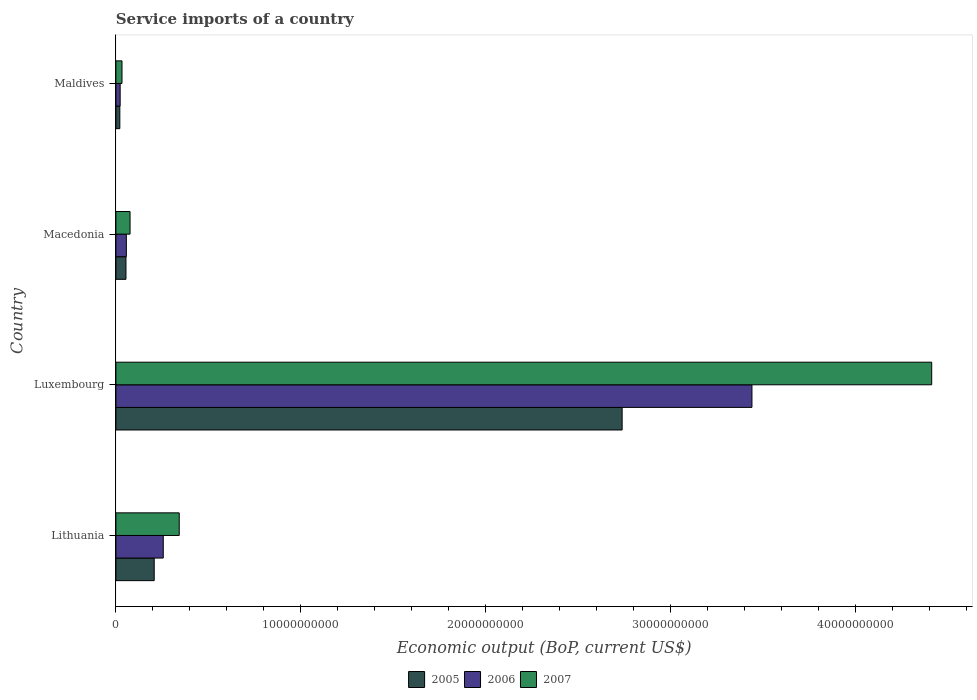How many different coloured bars are there?
Provide a succinct answer. 3. How many bars are there on the 2nd tick from the bottom?
Your answer should be very brief. 3. What is the label of the 1st group of bars from the top?
Your answer should be compact. Maldives. What is the service imports in 2007 in Lithuania?
Keep it short and to the point. 3.43e+09. Across all countries, what is the maximum service imports in 2005?
Offer a very short reply. 2.74e+1. Across all countries, what is the minimum service imports in 2007?
Provide a succinct answer. 3.31e+08. In which country was the service imports in 2005 maximum?
Give a very brief answer. Luxembourg. In which country was the service imports in 2007 minimum?
Your answer should be compact. Maldives. What is the total service imports in 2007 in the graph?
Your answer should be compact. 4.87e+1. What is the difference between the service imports in 2007 in Lithuania and that in Macedonia?
Ensure brevity in your answer.  2.66e+09. What is the difference between the service imports in 2007 in Maldives and the service imports in 2006 in Lithuania?
Provide a succinct answer. -2.23e+09. What is the average service imports in 2005 per country?
Your answer should be compact. 7.55e+09. What is the difference between the service imports in 2006 and service imports in 2007 in Lithuania?
Your answer should be compact. -8.64e+08. What is the ratio of the service imports in 2005 in Macedonia to that in Maldives?
Offer a very short reply. 2.56. Is the difference between the service imports in 2006 in Lithuania and Maldives greater than the difference between the service imports in 2007 in Lithuania and Maldives?
Offer a terse response. No. What is the difference between the highest and the second highest service imports in 2005?
Keep it short and to the point. 2.53e+1. What is the difference between the highest and the lowest service imports in 2006?
Your response must be concise. 3.42e+1. In how many countries, is the service imports in 2005 greater than the average service imports in 2005 taken over all countries?
Keep it short and to the point. 1. Is the sum of the service imports in 2005 in Macedonia and Maldives greater than the maximum service imports in 2007 across all countries?
Provide a succinct answer. No. What does the 3rd bar from the top in Lithuania represents?
Provide a short and direct response. 2005. What does the 3rd bar from the bottom in Macedonia represents?
Ensure brevity in your answer.  2007. Is it the case that in every country, the sum of the service imports in 2005 and service imports in 2007 is greater than the service imports in 2006?
Your answer should be compact. Yes. How many bars are there?
Provide a short and direct response. 12. Are all the bars in the graph horizontal?
Offer a very short reply. Yes. How many countries are there in the graph?
Ensure brevity in your answer.  4. Are the values on the major ticks of X-axis written in scientific E-notation?
Keep it short and to the point. No. How are the legend labels stacked?
Provide a succinct answer. Horizontal. What is the title of the graph?
Ensure brevity in your answer.  Service imports of a country. Does "1983" appear as one of the legend labels in the graph?
Your answer should be very brief. No. What is the label or title of the X-axis?
Make the answer very short. Economic output (BoP, current US$). What is the Economic output (BoP, current US$) in 2005 in Lithuania?
Keep it short and to the point. 2.07e+09. What is the Economic output (BoP, current US$) of 2006 in Lithuania?
Ensure brevity in your answer.  2.56e+09. What is the Economic output (BoP, current US$) of 2007 in Lithuania?
Provide a succinct answer. 3.43e+09. What is the Economic output (BoP, current US$) in 2005 in Luxembourg?
Your answer should be compact. 2.74e+1. What is the Economic output (BoP, current US$) of 2006 in Luxembourg?
Provide a short and direct response. 3.44e+1. What is the Economic output (BoP, current US$) in 2007 in Luxembourg?
Your answer should be compact. 4.41e+1. What is the Economic output (BoP, current US$) in 2005 in Macedonia?
Keep it short and to the point. 5.45e+08. What is the Economic output (BoP, current US$) in 2006 in Macedonia?
Offer a terse response. 5.66e+08. What is the Economic output (BoP, current US$) in 2007 in Macedonia?
Give a very brief answer. 7.66e+08. What is the Economic output (BoP, current US$) of 2005 in Maldives?
Ensure brevity in your answer.  2.13e+08. What is the Economic output (BoP, current US$) of 2006 in Maldives?
Provide a short and direct response. 2.31e+08. What is the Economic output (BoP, current US$) in 2007 in Maldives?
Keep it short and to the point. 3.31e+08. Across all countries, what is the maximum Economic output (BoP, current US$) of 2005?
Your answer should be compact. 2.74e+1. Across all countries, what is the maximum Economic output (BoP, current US$) in 2006?
Your response must be concise. 3.44e+1. Across all countries, what is the maximum Economic output (BoP, current US$) of 2007?
Make the answer very short. 4.41e+1. Across all countries, what is the minimum Economic output (BoP, current US$) of 2005?
Your response must be concise. 2.13e+08. Across all countries, what is the minimum Economic output (BoP, current US$) of 2006?
Provide a short and direct response. 2.31e+08. Across all countries, what is the minimum Economic output (BoP, current US$) of 2007?
Offer a very short reply. 3.31e+08. What is the total Economic output (BoP, current US$) of 2005 in the graph?
Provide a succinct answer. 3.02e+1. What is the total Economic output (BoP, current US$) of 2006 in the graph?
Make the answer very short. 3.78e+1. What is the total Economic output (BoP, current US$) of 2007 in the graph?
Provide a succinct answer. 4.87e+1. What is the difference between the Economic output (BoP, current US$) in 2005 in Lithuania and that in Luxembourg?
Give a very brief answer. -2.53e+1. What is the difference between the Economic output (BoP, current US$) in 2006 in Lithuania and that in Luxembourg?
Your answer should be very brief. -3.18e+1. What is the difference between the Economic output (BoP, current US$) in 2007 in Lithuania and that in Luxembourg?
Give a very brief answer. -4.07e+1. What is the difference between the Economic output (BoP, current US$) in 2005 in Lithuania and that in Macedonia?
Keep it short and to the point. 1.53e+09. What is the difference between the Economic output (BoP, current US$) in 2006 in Lithuania and that in Macedonia?
Provide a short and direct response. 2.00e+09. What is the difference between the Economic output (BoP, current US$) of 2007 in Lithuania and that in Macedonia?
Your response must be concise. 2.66e+09. What is the difference between the Economic output (BoP, current US$) in 2005 in Lithuania and that in Maldives?
Provide a succinct answer. 1.86e+09. What is the difference between the Economic output (BoP, current US$) in 2006 in Lithuania and that in Maldives?
Make the answer very short. 2.33e+09. What is the difference between the Economic output (BoP, current US$) of 2007 in Lithuania and that in Maldives?
Provide a short and direct response. 3.10e+09. What is the difference between the Economic output (BoP, current US$) in 2005 in Luxembourg and that in Macedonia?
Your response must be concise. 2.68e+1. What is the difference between the Economic output (BoP, current US$) of 2006 in Luxembourg and that in Macedonia?
Your response must be concise. 3.38e+1. What is the difference between the Economic output (BoP, current US$) in 2007 in Luxembourg and that in Macedonia?
Your answer should be very brief. 4.34e+1. What is the difference between the Economic output (BoP, current US$) in 2005 in Luxembourg and that in Maldives?
Your answer should be compact. 2.72e+1. What is the difference between the Economic output (BoP, current US$) in 2006 in Luxembourg and that in Maldives?
Your answer should be compact. 3.42e+1. What is the difference between the Economic output (BoP, current US$) of 2007 in Luxembourg and that in Maldives?
Offer a terse response. 4.38e+1. What is the difference between the Economic output (BoP, current US$) in 2005 in Macedonia and that in Maldives?
Give a very brief answer. 3.32e+08. What is the difference between the Economic output (BoP, current US$) in 2006 in Macedonia and that in Maldives?
Offer a terse response. 3.35e+08. What is the difference between the Economic output (BoP, current US$) of 2007 in Macedonia and that in Maldives?
Your answer should be compact. 4.35e+08. What is the difference between the Economic output (BoP, current US$) in 2005 in Lithuania and the Economic output (BoP, current US$) in 2006 in Luxembourg?
Give a very brief answer. -3.23e+1. What is the difference between the Economic output (BoP, current US$) in 2005 in Lithuania and the Economic output (BoP, current US$) in 2007 in Luxembourg?
Provide a succinct answer. -4.21e+1. What is the difference between the Economic output (BoP, current US$) of 2006 in Lithuania and the Economic output (BoP, current US$) of 2007 in Luxembourg?
Make the answer very short. -4.16e+1. What is the difference between the Economic output (BoP, current US$) in 2005 in Lithuania and the Economic output (BoP, current US$) in 2006 in Macedonia?
Provide a succinct answer. 1.51e+09. What is the difference between the Economic output (BoP, current US$) of 2005 in Lithuania and the Economic output (BoP, current US$) of 2007 in Macedonia?
Your answer should be very brief. 1.31e+09. What is the difference between the Economic output (BoP, current US$) of 2006 in Lithuania and the Economic output (BoP, current US$) of 2007 in Macedonia?
Keep it short and to the point. 1.80e+09. What is the difference between the Economic output (BoP, current US$) in 2005 in Lithuania and the Economic output (BoP, current US$) in 2006 in Maldives?
Make the answer very short. 1.84e+09. What is the difference between the Economic output (BoP, current US$) in 2005 in Lithuania and the Economic output (BoP, current US$) in 2007 in Maldives?
Make the answer very short. 1.74e+09. What is the difference between the Economic output (BoP, current US$) in 2006 in Lithuania and the Economic output (BoP, current US$) in 2007 in Maldives?
Give a very brief answer. 2.23e+09. What is the difference between the Economic output (BoP, current US$) in 2005 in Luxembourg and the Economic output (BoP, current US$) in 2006 in Macedonia?
Give a very brief answer. 2.68e+1. What is the difference between the Economic output (BoP, current US$) in 2005 in Luxembourg and the Economic output (BoP, current US$) in 2007 in Macedonia?
Keep it short and to the point. 2.66e+1. What is the difference between the Economic output (BoP, current US$) of 2006 in Luxembourg and the Economic output (BoP, current US$) of 2007 in Macedonia?
Your answer should be compact. 3.36e+1. What is the difference between the Economic output (BoP, current US$) in 2005 in Luxembourg and the Economic output (BoP, current US$) in 2006 in Maldives?
Provide a succinct answer. 2.72e+1. What is the difference between the Economic output (BoP, current US$) in 2005 in Luxembourg and the Economic output (BoP, current US$) in 2007 in Maldives?
Offer a terse response. 2.71e+1. What is the difference between the Economic output (BoP, current US$) in 2006 in Luxembourg and the Economic output (BoP, current US$) in 2007 in Maldives?
Ensure brevity in your answer.  3.41e+1. What is the difference between the Economic output (BoP, current US$) of 2005 in Macedonia and the Economic output (BoP, current US$) of 2006 in Maldives?
Your answer should be very brief. 3.14e+08. What is the difference between the Economic output (BoP, current US$) of 2005 in Macedonia and the Economic output (BoP, current US$) of 2007 in Maldives?
Provide a short and direct response. 2.14e+08. What is the difference between the Economic output (BoP, current US$) in 2006 in Macedonia and the Economic output (BoP, current US$) in 2007 in Maldives?
Offer a terse response. 2.35e+08. What is the average Economic output (BoP, current US$) of 2005 per country?
Make the answer very short. 7.55e+09. What is the average Economic output (BoP, current US$) in 2006 per country?
Make the answer very short. 9.44e+09. What is the average Economic output (BoP, current US$) of 2007 per country?
Your response must be concise. 1.22e+1. What is the difference between the Economic output (BoP, current US$) in 2005 and Economic output (BoP, current US$) in 2006 in Lithuania?
Your answer should be very brief. -4.90e+08. What is the difference between the Economic output (BoP, current US$) of 2005 and Economic output (BoP, current US$) of 2007 in Lithuania?
Your response must be concise. -1.35e+09. What is the difference between the Economic output (BoP, current US$) in 2006 and Economic output (BoP, current US$) in 2007 in Lithuania?
Provide a succinct answer. -8.64e+08. What is the difference between the Economic output (BoP, current US$) in 2005 and Economic output (BoP, current US$) in 2006 in Luxembourg?
Your response must be concise. -7.02e+09. What is the difference between the Economic output (BoP, current US$) of 2005 and Economic output (BoP, current US$) of 2007 in Luxembourg?
Offer a very short reply. -1.67e+1. What is the difference between the Economic output (BoP, current US$) in 2006 and Economic output (BoP, current US$) in 2007 in Luxembourg?
Your answer should be very brief. -9.72e+09. What is the difference between the Economic output (BoP, current US$) in 2005 and Economic output (BoP, current US$) in 2006 in Macedonia?
Make the answer very short. -2.10e+07. What is the difference between the Economic output (BoP, current US$) in 2005 and Economic output (BoP, current US$) in 2007 in Macedonia?
Offer a very short reply. -2.21e+08. What is the difference between the Economic output (BoP, current US$) in 2006 and Economic output (BoP, current US$) in 2007 in Macedonia?
Give a very brief answer. -2.00e+08. What is the difference between the Economic output (BoP, current US$) of 2005 and Economic output (BoP, current US$) of 2006 in Maldives?
Your answer should be very brief. -1.81e+07. What is the difference between the Economic output (BoP, current US$) of 2005 and Economic output (BoP, current US$) of 2007 in Maldives?
Provide a succinct answer. -1.18e+08. What is the difference between the Economic output (BoP, current US$) of 2006 and Economic output (BoP, current US$) of 2007 in Maldives?
Give a very brief answer. -9.97e+07. What is the ratio of the Economic output (BoP, current US$) of 2005 in Lithuania to that in Luxembourg?
Ensure brevity in your answer.  0.08. What is the ratio of the Economic output (BoP, current US$) of 2006 in Lithuania to that in Luxembourg?
Your answer should be very brief. 0.07. What is the ratio of the Economic output (BoP, current US$) in 2007 in Lithuania to that in Luxembourg?
Make the answer very short. 0.08. What is the ratio of the Economic output (BoP, current US$) of 2005 in Lithuania to that in Macedonia?
Provide a short and direct response. 3.8. What is the ratio of the Economic output (BoP, current US$) of 2006 in Lithuania to that in Macedonia?
Your answer should be very brief. 4.53. What is the ratio of the Economic output (BoP, current US$) in 2007 in Lithuania to that in Macedonia?
Your answer should be compact. 4.47. What is the ratio of the Economic output (BoP, current US$) in 2005 in Lithuania to that in Maldives?
Your answer should be compact. 9.73. What is the ratio of the Economic output (BoP, current US$) in 2006 in Lithuania to that in Maldives?
Provide a succinct answer. 11.08. What is the ratio of the Economic output (BoP, current US$) in 2007 in Lithuania to that in Maldives?
Offer a terse response. 10.35. What is the ratio of the Economic output (BoP, current US$) of 2005 in Luxembourg to that in Macedonia?
Make the answer very short. 50.23. What is the ratio of the Economic output (BoP, current US$) of 2006 in Luxembourg to that in Macedonia?
Your answer should be compact. 60.77. What is the ratio of the Economic output (BoP, current US$) in 2007 in Luxembourg to that in Macedonia?
Give a very brief answer. 57.64. What is the ratio of the Economic output (BoP, current US$) in 2005 in Luxembourg to that in Maldives?
Offer a very short reply. 128.53. What is the ratio of the Economic output (BoP, current US$) of 2006 in Luxembourg to that in Maldives?
Your answer should be compact. 148.84. What is the ratio of the Economic output (BoP, current US$) in 2007 in Luxembourg to that in Maldives?
Offer a very short reply. 133.37. What is the ratio of the Economic output (BoP, current US$) in 2005 in Macedonia to that in Maldives?
Make the answer very short. 2.56. What is the ratio of the Economic output (BoP, current US$) in 2006 in Macedonia to that in Maldives?
Make the answer very short. 2.45. What is the ratio of the Economic output (BoP, current US$) of 2007 in Macedonia to that in Maldives?
Ensure brevity in your answer.  2.31. What is the difference between the highest and the second highest Economic output (BoP, current US$) in 2005?
Your response must be concise. 2.53e+1. What is the difference between the highest and the second highest Economic output (BoP, current US$) of 2006?
Give a very brief answer. 3.18e+1. What is the difference between the highest and the second highest Economic output (BoP, current US$) in 2007?
Ensure brevity in your answer.  4.07e+1. What is the difference between the highest and the lowest Economic output (BoP, current US$) of 2005?
Ensure brevity in your answer.  2.72e+1. What is the difference between the highest and the lowest Economic output (BoP, current US$) of 2006?
Your answer should be compact. 3.42e+1. What is the difference between the highest and the lowest Economic output (BoP, current US$) in 2007?
Offer a very short reply. 4.38e+1. 